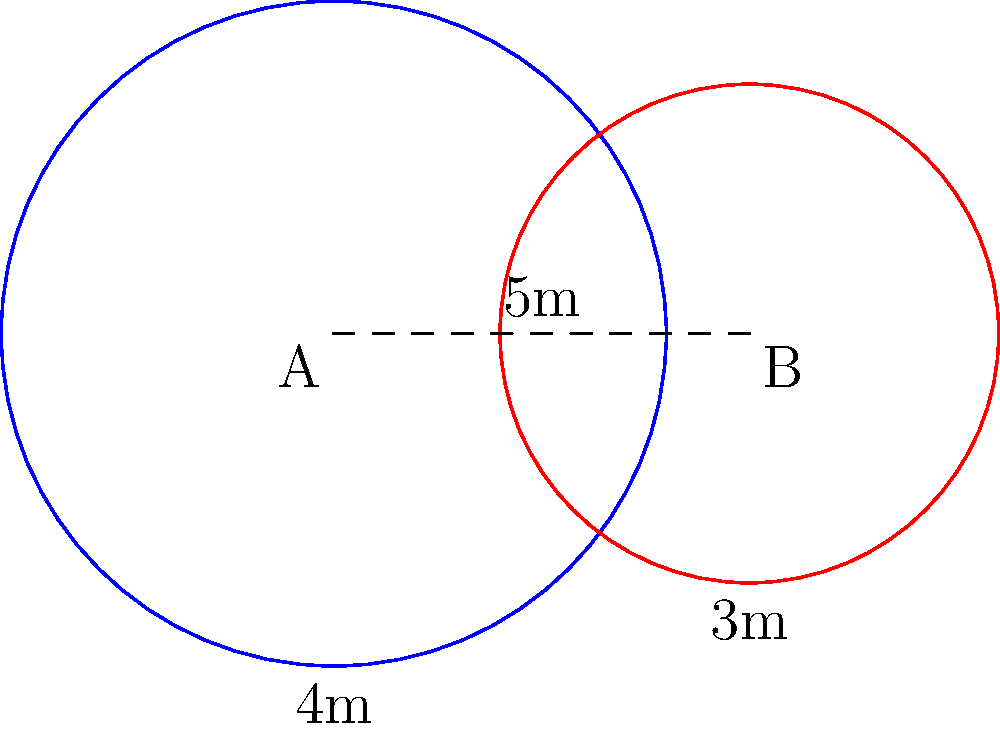On your soccer field, you've set up two circular training zones. Zone A has a radius of 4 meters, and Zone B has a radius of 3 meters. The centers of these zones are 5 meters apart. What is the area of the overlapping region between these two zones? Round your answer to the nearest square meter. To find the area of overlap between two circles, we can use the following steps:

1) First, we need to calculate the distance $d$ between the centers of the circles. We're given this: $d = 5$ meters.

2) Next, we'll use the formula for the area of overlap:

   $A = r_1^2 \arccos(\frac{d^2 + r_1^2 - r_2^2}{2dr_1}) + r_2^2 \arccos(\frac{d^2 + r_2^2 - r_1^2}{2dr_2}) - \frac{1}{2}\sqrt{(-d+r_1+r_2)(d+r_1-r_2)(d-r_1+r_2)(d+r_1+r_2)}$

   Where $r_1 = 4$ (radius of Zone A) and $r_2 = 3$ (radius of Zone B)

3) Let's substitute these values:

   $A = 4^2 \arccos(\frac{5^2 + 4^2 - 3^2}{2 \cdot 5 \cdot 4}) + 3^2 \arccos(\frac{5^2 + 3^2 - 4^2}{2 \cdot 5 \cdot 3}) - \frac{1}{2}\sqrt{(-5+4+3)(5+4-3)(5-4+3)(5+4+3)}$

4) Simplifying:

   $A = 16 \arccos(\frac{25 + 16 - 9}{40}) + 9 \arccos(\frac{25 + 9 - 16}{30}) - \frac{1}{2}\sqrt{(2)(6)(4)(12)}$

   $A = 16 \arccos(0.8) + 9 \arccos(0.6) - \frac{1}{2}\sqrt{576}$

5) Calculating:

   $A \approx 16 \cdot 0.6435 + 9 \cdot 0.9273 - \frac{1}{2} \cdot 24$

   $A \approx 10.296 + 8.3457 - 12$

   $A \approx 6.6417$

6) Rounding to the nearest square meter:

   $A \approx 7$ square meters
Answer: 7 square meters 